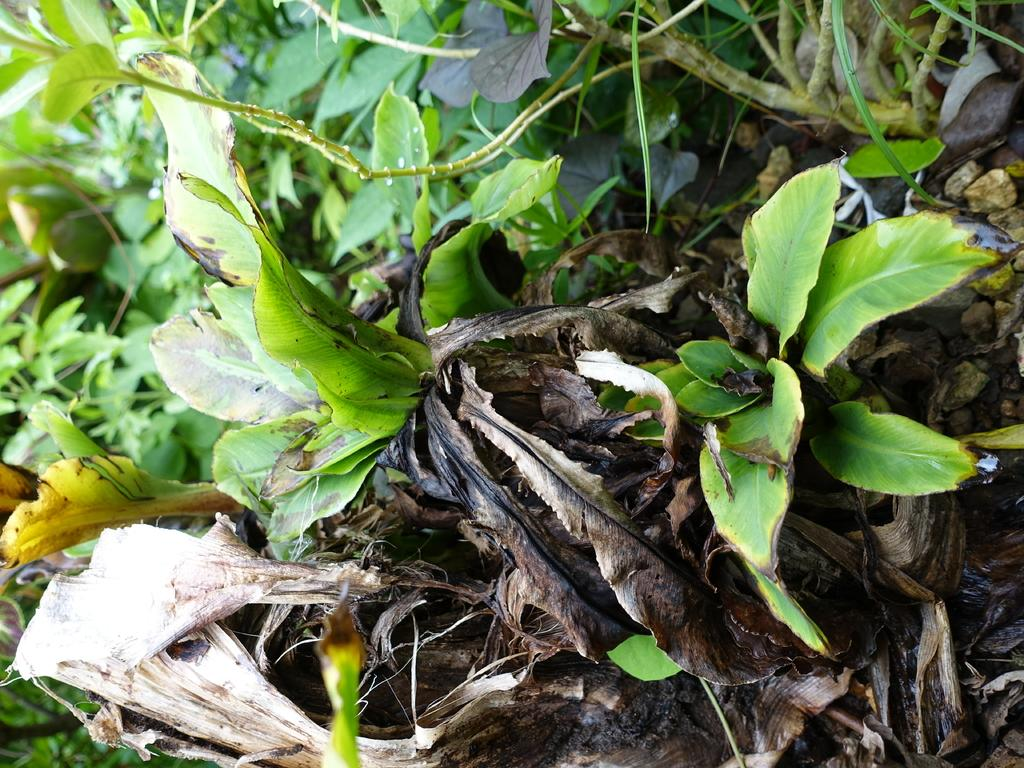What type of living organisms can be seen in the image? There are many plants in the image. What is the condition of some of the leaves on the plants? There are dry leaves in the image. What type of joke is the sister telling in the image? There is no sister or joke present in the image; it only features plants and dry leaves. 